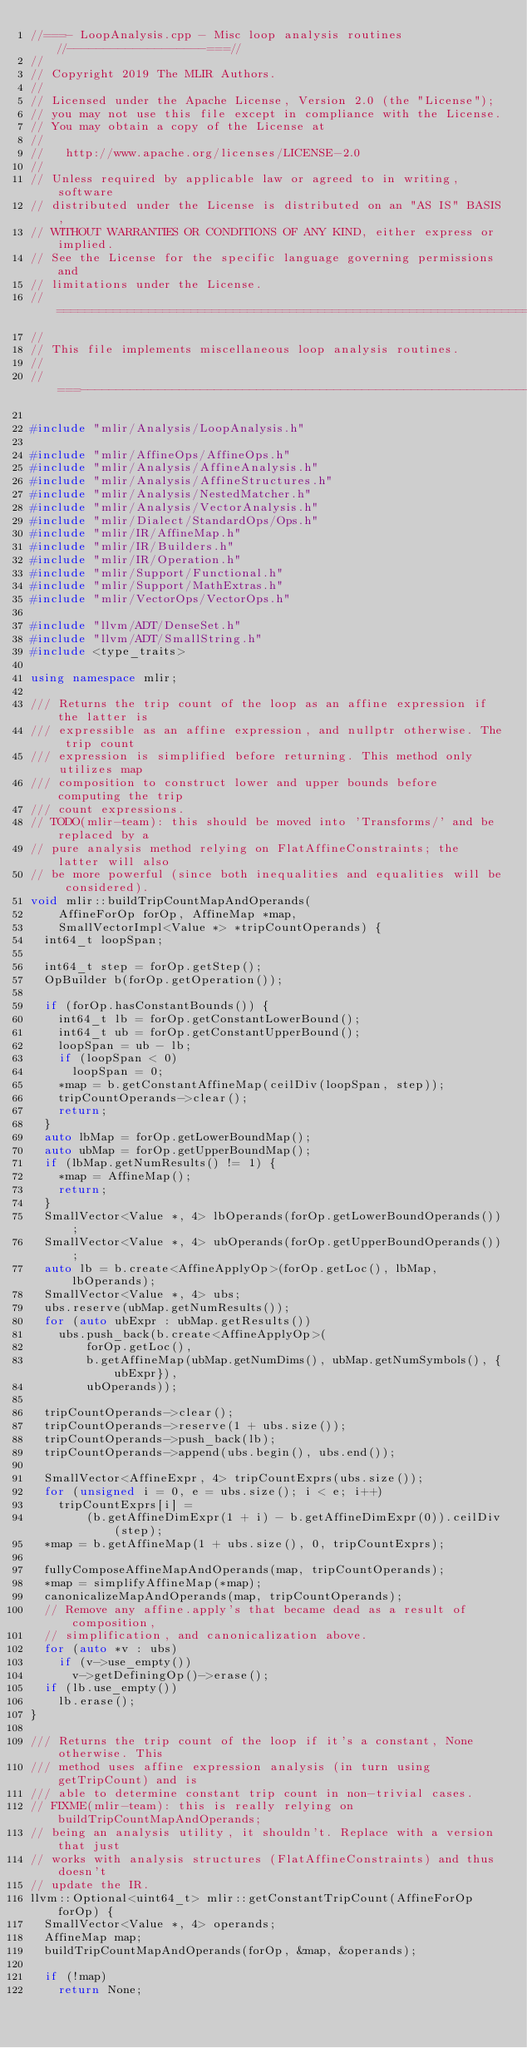<code> <loc_0><loc_0><loc_500><loc_500><_C++_>//===- LoopAnalysis.cpp - Misc loop analysis routines //-------------------===//
//
// Copyright 2019 The MLIR Authors.
//
// Licensed under the Apache License, Version 2.0 (the "License");
// you may not use this file except in compliance with the License.
// You may obtain a copy of the License at
//
//   http://www.apache.org/licenses/LICENSE-2.0
//
// Unless required by applicable law or agreed to in writing, software
// distributed under the License is distributed on an "AS IS" BASIS,
// WITHOUT WARRANTIES OR CONDITIONS OF ANY KIND, either express or implied.
// See the License for the specific language governing permissions and
// limitations under the License.
// =============================================================================
//
// This file implements miscellaneous loop analysis routines.
//
//===----------------------------------------------------------------------===//

#include "mlir/Analysis/LoopAnalysis.h"

#include "mlir/AffineOps/AffineOps.h"
#include "mlir/Analysis/AffineAnalysis.h"
#include "mlir/Analysis/AffineStructures.h"
#include "mlir/Analysis/NestedMatcher.h"
#include "mlir/Analysis/VectorAnalysis.h"
#include "mlir/Dialect/StandardOps/Ops.h"
#include "mlir/IR/AffineMap.h"
#include "mlir/IR/Builders.h"
#include "mlir/IR/Operation.h"
#include "mlir/Support/Functional.h"
#include "mlir/Support/MathExtras.h"
#include "mlir/VectorOps/VectorOps.h"

#include "llvm/ADT/DenseSet.h"
#include "llvm/ADT/SmallString.h"
#include <type_traits>

using namespace mlir;

/// Returns the trip count of the loop as an affine expression if the latter is
/// expressible as an affine expression, and nullptr otherwise. The trip count
/// expression is simplified before returning. This method only utilizes map
/// composition to construct lower and upper bounds before computing the trip
/// count expressions.
// TODO(mlir-team): this should be moved into 'Transforms/' and be replaced by a
// pure analysis method relying on FlatAffineConstraints; the latter will also
// be more powerful (since both inequalities and equalities will be considered).
void mlir::buildTripCountMapAndOperands(
    AffineForOp forOp, AffineMap *map,
    SmallVectorImpl<Value *> *tripCountOperands) {
  int64_t loopSpan;

  int64_t step = forOp.getStep();
  OpBuilder b(forOp.getOperation());

  if (forOp.hasConstantBounds()) {
    int64_t lb = forOp.getConstantLowerBound();
    int64_t ub = forOp.getConstantUpperBound();
    loopSpan = ub - lb;
    if (loopSpan < 0)
      loopSpan = 0;
    *map = b.getConstantAffineMap(ceilDiv(loopSpan, step));
    tripCountOperands->clear();
    return;
  }
  auto lbMap = forOp.getLowerBoundMap();
  auto ubMap = forOp.getUpperBoundMap();
  if (lbMap.getNumResults() != 1) {
    *map = AffineMap();
    return;
  }
  SmallVector<Value *, 4> lbOperands(forOp.getLowerBoundOperands());
  SmallVector<Value *, 4> ubOperands(forOp.getUpperBoundOperands());
  auto lb = b.create<AffineApplyOp>(forOp.getLoc(), lbMap, lbOperands);
  SmallVector<Value *, 4> ubs;
  ubs.reserve(ubMap.getNumResults());
  for (auto ubExpr : ubMap.getResults())
    ubs.push_back(b.create<AffineApplyOp>(
        forOp.getLoc(),
        b.getAffineMap(ubMap.getNumDims(), ubMap.getNumSymbols(), {ubExpr}),
        ubOperands));

  tripCountOperands->clear();
  tripCountOperands->reserve(1 + ubs.size());
  tripCountOperands->push_back(lb);
  tripCountOperands->append(ubs.begin(), ubs.end());

  SmallVector<AffineExpr, 4> tripCountExprs(ubs.size());
  for (unsigned i = 0, e = ubs.size(); i < e; i++)
    tripCountExprs[i] =
        (b.getAffineDimExpr(1 + i) - b.getAffineDimExpr(0)).ceilDiv(step);
  *map = b.getAffineMap(1 + ubs.size(), 0, tripCountExprs);

  fullyComposeAffineMapAndOperands(map, tripCountOperands);
  *map = simplifyAffineMap(*map);
  canonicalizeMapAndOperands(map, tripCountOperands);
  // Remove any affine.apply's that became dead as a result of composition,
  // simplification, and canonicalization above.
  for (auto *v : ubs)
    if (v->use_empty())
      v->getDefiningOp()->erase();
  if (lb.use_empty())
    lb.erase();
}

/// Returns the trip count of the loop if it's a constant, None otherwise. This
/// method uses affine expression analysis (in turn using getTripCount) and is
/// able to determine constant trip count in non-trivial cases.
// FIXME(mlir-team): this is really relying on buildTripCountMapAndOperands;
// being an analysis utility, it shouldn't. Replace with a version that just
// works with analysis structures (FlatAffineConstraints) and thus doesn't
// update the IR.
llvm::Optional<uint64_t> mlir::getConstantTripCount(AffineForOp forOp) {
  SmallVector<Value *, 4> operands;
  AffineMap map;
  buildTripCountMapAndOperands(forOp, &map, &operands);

  if (!map)
    return None;
</code> 